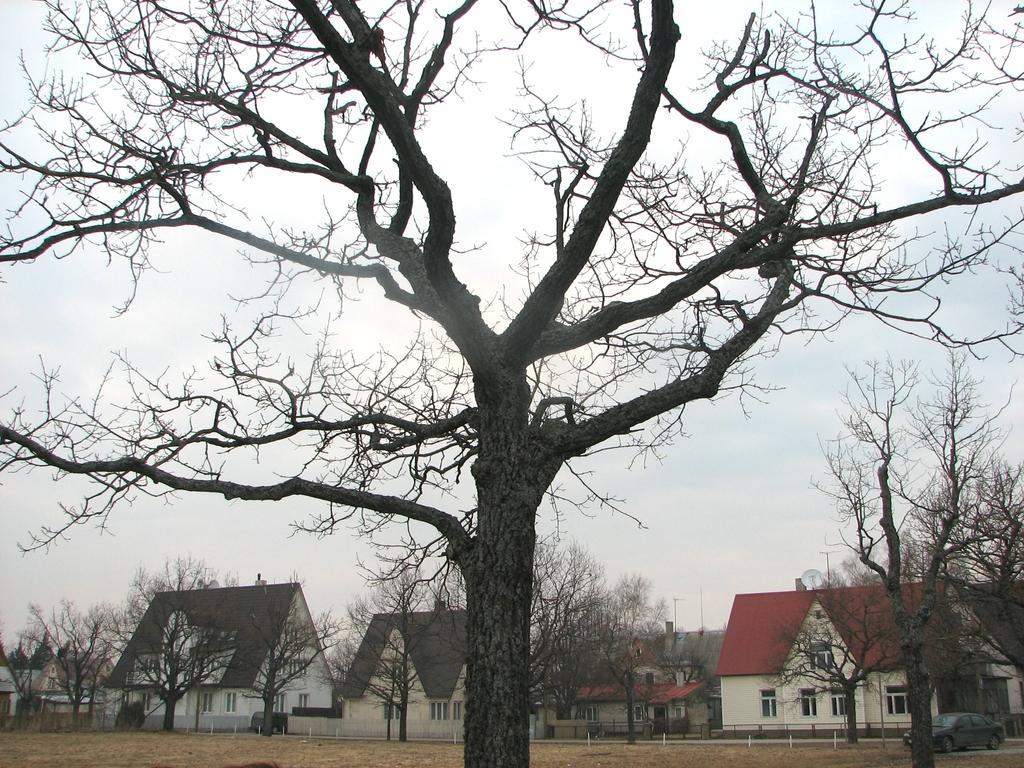How would you summarize this image in a sentence or two? In this image we can see tree. In the background there are trees and buildings with windows. In the background there is sky. Also there is a car. 